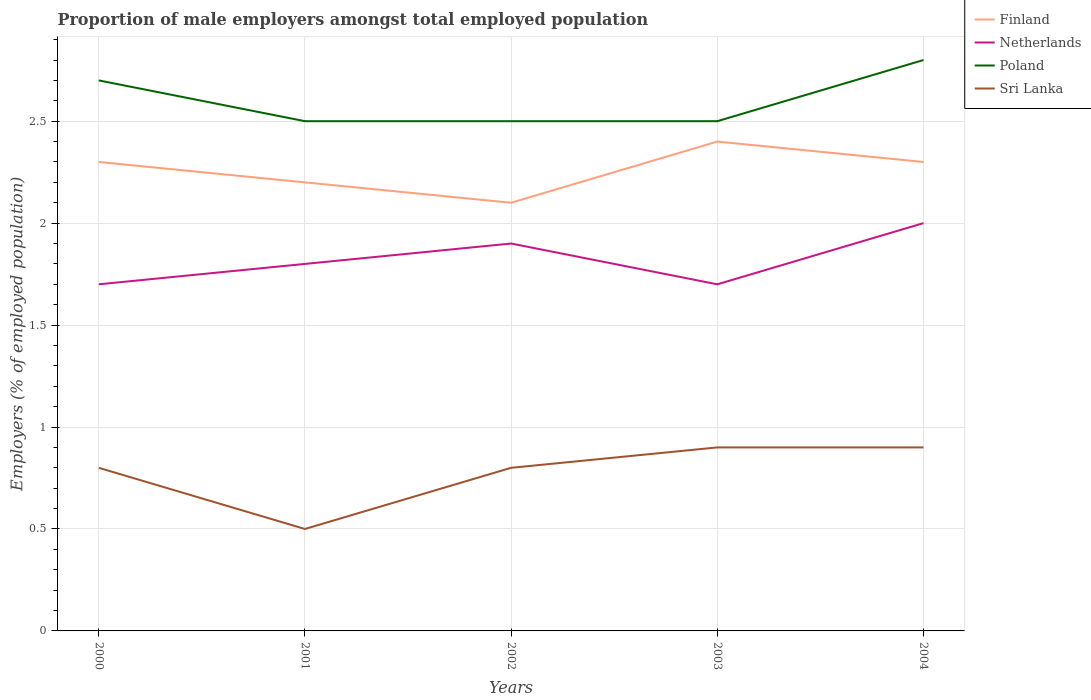How many different coloured lines are there?
Your response must be concise. 4. Is the number of lines equal to the number of legend labels?
Offer a terse response. Yes. Across all years, what is the maximum proportion of male employers in Sri Lanka?
Your response must be concise. 0.5. In which year was the proportion of male employers in Sri Lanka maximum?
Ensure brevity in your answer.  2001. What is the total proportion of male employers in Netherlands in the graph?
Ensure brevity in your answer.  -0.1. What is the difference between the highest and the second highest proportion of male employers in Poland?
Offer a terse response. 0.3. What is the difference between the highest and the lowest proportion of male employers in Finland?
Your answer should be compact. 3. Is the proportion of male employers in Sri Lanka strictly greater than the proportion of male employers in Netherlands over the years?
Ensure brevity in your answer.  Yes. What is the difference between two consecutive major ticks on the Y-axis?
Provide a succinct answer. 0.5. Are the values on the major ticks of Y-axis written in scientific E-notation?
Provide a short and direct response. No. Does the graph contain any zero values?
Provide a short and direct response. No. Does the graph contain grids?
Make the answer very short. Yes. What is the title of the graph?
Provide a short and direct response. Proportion of male employers amongst total employed population. Does "Hong Kong" appear as one of the legend labels in the graph?
Your answer should be compact. No. What is the label or title of the Y-axis?
Offer a very short reply. Employers (% of employed population). What is the Employers (% of employed population) in Finland in 2000?
Keep it short and to the point. 2.3. What is the Employers (% of employed population) in Netherlands in 2000?
Your answer should be very brief. 1.7. What is the Employers (% of employed population) of Poland in 2000?
Provide a short and direct response. 2.7. What is the Employers (% of employed population) in Sri Lanka in 2000?
Offer a terse response. 0.8. What is the Employers (% of employed population) of Finland in 2001?
Give a very brief answer. 2.2. What is the Employers (% of employed population) of Netherlands in 2001?
Make the answer very short. 1.8. What is the Employers (% of employed population) in Poland in 2001?
Offer a very short reply. 2.5. What is the Employers (% of employed population) of Finland in 2002?
Provide a short and direct response. 2.1. What is the Employers (% of employed population) of Netherlands in 2002?
Your response must be concise. 1.9. What is the Employers (% of employed population) of Sri Lanka in 2002?
Provide a succinct answer. 0.8. What is the Employers (% of employed population) in Finland in 2003?
Your response must be concise. 2.4. What is the Employers (% of employed population) of Netherlands in 2003?
Ensure brevity in your answer.  1.7. What is the Employers (% of employed population) of Sri Lanka in 2003?
Provide a short and direct response. 0.9. What is the Employers (% of employed population) in Finland in 2004?
Offer a very short reply. 2.3. What is the Employers (% of employed population) of Poland in 2004?
Your answer should be very brief. 2.8. What is the Employers (% of employed population) in Sri Lanka in 2004?
Offer a very short reply. 0.9. Across all years, what is the maximum Employers (% of employed population) of Finland?
Your response must be concise. 2.4. Across all years, what is the maximum Employers (% of employed population) of Netherlands?
Your response must be concise. 2. Across all years, what is the maximum Employers (% of employed population) of Poland?
Provide a short and direct response. 2.8. Across all years, what is the maximum Employers (% of employed population) in Sri Lanka?
Provide a succinct answer. 0.9. Across all years, what is the minimum Employers (% of employed population) of Finland?
Keep it short and to the point. 2.1. Across all years, what is the minimum Employers (% of employed population) of Netherlands?
Make the answer very short. 1.7. Across all years, what is the minimum Employers (% of employed population) of Sri Lanka?
Your answer should be very brief. 0.5. What is the total Employers (% of employed population) in Finland in the graph?
Offer a very short reply. 11.3. What is the total Employers (% of employed population) in Netherlands in the graph?
Provide a short and direct response. 9.1. What is the total Employers (% of employed population) of Poland in the graph?
Make the answer very short. 13. What is the total Employers (% of employed population) in Sri Lanka in the graph?
Keep it short and to the point. 3.9. What is the difference between the Employers (% of employed population) of Poland in 2000 and that in 2001?
Offer a very short reply. 0.2. What is the difference between the Employers (% of employed population) of Netherlands in 2000 and that in 2002?
Provide a short and direct response. -0.2. What is the difference between the Employers (% of employed population) in Poland in 2000 and that in 2002?
Your response must be concise. 0.2. What is the difference between the Employers (% of employed population) of Sri Lanka in 2000 and that in 2002?
Your answer should be very brief. 0. What is the difference between the Employers (% of employed population) in Finland in 2000 and that in 2003?
Your answer should be very brief. -0.1. What is the difference between the Employers (% of employed population) in Poland in 2000 and that in 2003?
Provide a short and direct response. 0.2. What is the difference between the Employers (% of employed population) of Netherlands in 2000 and that in 2004?
Offer a terse response. -0.3. What is the difference between the Employers (% of employed population) in Sri Lanka in 2000 and that in 2004?
Give a very brief answer. -0.1. What is the difference between the Employers (% of employed population) in Finland in 2001 and that in 2002?
Provide a short and direct response. 0.1. What is the difference between the Employers (% of employed population) in Netherlands in 2001 and that in 2002?
Make the answer very short. -0.1. What is the difference between the Employers (% of employed population) in Poland in 2001 and that in 2002?
Your answer should be compact. 0. What is the difference between the Employers (% of employed population) of Netherlands in 2001 and that in 2003?
Give a very brief answer. 0.1. What is the difference between the Employers (% of employed population) in Poland in 2001 and that in 2004?
Make the answer very short. -0.3. What is the difference between the Employers (% of employed population) of Sri Lanka in 2001 and that in 2004?
Offer a very short reply. -0.4. What is the difference between the Employers (% of employed population) in Finland in 2002 and that in 2003?
Make the answer very short. -0.3. What is the difference between the Employers (% of employed population) of Poland in 2002 and that in 2003?
Provide a short and direct response. 0. What is the difference between the Employers (% of employed population) of Finland in 2002 and that in 2004?
Your answer should be very brief. -0.2. What is the difference between the Employers (% of employed population) in Poland in 2002 and that in 2004?
Your answer should be very brief. -0.3. What is the difference between the Employers (% of employed population) in Poland in 2003 and that in 2004?
Keep it short and to the point. -0.3. What is the difference between the Employers (% of employed population) in Netherlands in 2000 and the Employers (% of employed population) in Sri Lanka in 2001?
Make the answer very short. 1.2. What is the difference between the Employers (% of employed population) in Poland in 2000 and the Employers (% of employed population) in Sri Lanka in 2001?
Provide a short and direct response. 2.2. What is the difference between the Employers (% of employed population) in Finland in 2000 and the Employers (% of employed population) in Poland in 2002?
Your answer should be very brief. -0.2. What is the difference between the Employers (% of employed population) of Finland in 2000 and the Employers (% of employed population) of Poland in 2003?
Provide a short and direct response. -0.2. What is the difference between the Employers (% of employed population) of Netherlands in 2000 and the Employers (% of employed population) of Poland in 2003?
Your answer should be compact. -0.8. What is the difference between the Employers (% of employed population) of Netherlands in 2000 and the Employers (% of employed population) of Sri Lanka in 2003?
Offer a terse response. 0.8. What is the difference between the Employers (% of employed population) of Finland in 2000 and the Employers (% of employed population) of Netherlands in 2004?
Your response must be concise. 0.3. What is the difference between the Employers (% of employed population) in Finland in 2000 and the Employers (% of employed population) in Poland in 2004?
Your answer should be very brief. -0.5. What is the difference between the Employers (% of employed population) in Finland in 2000 and the Employers (% of employed population) in Sri Lanka in 2004?
Your answer should be compact. 1.4. What is the difference between the Employers (% of employed population) of Finland in 2001 and the Employers (% of employed population) of Sri Lanka in 2002?
Your response must be concise. 1.4. What is the difference between the Employers (% of employed population) of Netherlands in 2001 and the Employers (% of employed population) of Poland in 2002?
Provide a succinct answer. -0.7. What is the difference between the Employers (% of employed population) in Netherlands in 2001 and the Employers (% of employed population) in Sri Lanka in 2002?
Provide a short and direct response. 1. What is the difference between the Employers (% of employed population) of Poland in 2001 and the Employers (% of employed population) of Sri Lanka in 2002?
Keep it short and to the point. 1.7. What is the difference between the Employers (% of employed population) in Finland in 2001 and the Employers (% of employed population) in Netherlands in 2003?
Make the answer very short. 0.5. What is the difference between the Employers (% of employed population) in Finland in 2001 and the Employers (% of employed population) in Poland in 2003?
Give a very brief answer. -0.3. What is the difference between the Employers (% of employed population) in Finland in 2001 and the Employers (% of employed population) in Sri Lanka in 2003?
Provide a succinct answer. 1.3. What is the difference between the Employers (% of employed population) in Netherlands in 2001 and the Employers (% of employed population) in Poland in 2003?
Give a very brief answer. -0.7. What is the difference between the Employers (% of employed population) of Finland in 2001 and the Employers (% of employed population) of Poland in 2004?
Ensure brevity in your answer.  -0.6. What is the difference between the Employers (% of employed population) of Netherlands in 2001 and the Employers (% of employed population) of Sri Lanka in 2004?
Keep it short and to the point. 0.9. What is the difference between the Employers (% of employed population) of Finland in 2002 and the Employers (% of employed population) of Poland in 2003?
Offer a very short reply. -0.4. What is the difference between the Employers (% of employed population) of Finland in 2002 and the Employers (% of employed population) of Sri Lanka in 2003?
Provide a succinct answer. 1.2. What is the difference between the Employers (% of employed population) in Netherlands in 2002 and the Employers (% of employed population) in Poland in 2003?
Offer a very short reply. -0.6. What is the difference between the Employers (% of employed population) in Netherlands in 2002 and the Employers (% of employed population) in Sri Lanka in 2003?
Provide a short and direct response. 1. What is the difference between the Employers (% of employed population) in Poland in 2002 and the Employers (% of employed population) in Sri Lanka in 2003?
Give a very brief answer. 1.6. What is the difference between the Employers (% of employed population) of Finland in 2002 and the Employers (% of employed population) of Netherlands in 2004?
Your response must be concise. 0.1. What is the difference between the Employers (% of employed population) in Finland in 2002 and the Employers (% of employed population) in Sri Lanka in 2004?
Your response must be concise. 1.2. What is the difference between the Employers (% of employed population) of Netherlands in 2002 and the Employers (% of employed population) of Poland in 2004?
Make the answer very short. -0.9. What is the difference between the Employers (% of employed population) in Finland in 2003 and the Employers (% of employed population) in Poland in 2004?
Offer a terse response. -0.4. What is the difference between the Employers (% of employed population) of Netherlands in 2003 and the Employers (% of employed population) of Poland in 2004?
Your answer should be very brief. -1.1. What is the difference between the Employers (% of employed population) of Poland in 2003 and the Employers (% of employed population) of Sri Lanka in 2004?
Make the answer very short. 1.6. What is the average Employers (% of employed population) of Finland per year?
Make the answer very short. 2.26. What is the average Employers (% of employed population) in Netherlands per year?
Your answer should be very brief. 1.82. What is the average Employers (% of employed population) in Sri Lanka per year?
Make the answer very short. 0.78. In the year 2000, what is the difference between the Employers (% of employed population) of Finland and Employers (% of employed population) of Netherlands?
Provide a succinct answer. 0.6. In the year 2000, what is the difference between the Employers (% of employed population) in Finland and Employers (% of employed population) in Poland?
Provide a short and direct response. -0.4. In the year 2000, what is the difference between the Employers (% of employed population) in Netherlands and Employers (% of employed population) in Poland?
Keep it short and to the point. -1. In the year 2001, what is the difference between the Employers (% of employed population) in Finland and Employers (% of employed population) in Poland?
Provide a succinct answer. -0.3. In the year 2001, what is the difference between the Employers (% of employed population) in Finland and Employers (% of employed population) in Sri Lanka?
Your response must be concise. 1.7. In the year 2001, what is the difference between the Employers (% of employed population) of Netherlands and Employers (% of employed population) of Sri Lanka?
Your answer should be very brief. 1.3. In the year 2002, what is the difference between the Employers (% of employed population) of Poland and Employers (% of employed population) of Sri Lanka?
Keep it short and to the point. 1.7. In the year 2003, what is the difference between the Employers (% of employed population) in Finland and Employers (% of employed population) in Poland?
Keep it short and to the point. -0.1. In the year 2003, what is the difference between the Employers (% of employed population) in Finland and Employers (% of employed population) in Sri Lanka?
Your answer should be very brief. 1.5. In the year 2003, what is the difference between the Employers (% of employed population) in Poland and Employers (% of employed population) in Sri Lanka?
Provide a short and direct response. 1.6. In the year 2004, what is the difference between the Employers (% of employed population) in Finland and Employers (% of employed population) in Netherlands?
Your answer should be compact. 0.3. In the year 2004, what is the difference between the Employers (% of employed population) of Finland and Employers (% of employed population) of Poland?
Make the answer very short. -0.5. What is the ratio of the Employers (% of employed population) of Finland in 2000 to that in 2001?
Offer a terse response. 1.05. What is the ratio of the Employers (% of employed population) of Netherlands in 2000 to that in 2001?
Make the answer very short. 0.94. What is the ratio of the Employers (% of employed population) of Poland in 2000 to that in 2001?
Your answer should be very brief. 1.08. What is the ratio of the Employers (% of employed population) of Finland in 2000 to that in 2002?
Ensure brevity in your answer.  1.1. What is the ratio of the Employers (% of employed population) of Netherlands in 2000 to that in 2002?
Provide a succinct answer. 0.89. What is the ratio of the Employers (% of employed population) in Sri Lanka in 2000 to that in 2002?
Provide a short and direct response. 1. What is the ratio of the Employers (% of employed population) in Finland in 2000 to that in 2003?
Your answer should be very brief. 0.96. What is the ratio of the Employers (% of employed population) of Sri Lanka in 2000 to that in 2003?
Your response must be concise. 0.89. What is the ratio of the Employers (% of employed population) in Netherlands in 2000 to that in 2004?
Give a very brief answer. 0.85. What is the ratio of the Employers (% of employed population) in Sri Lanka in 2000 to that in 2004?
Your answer should be compact. 0.89. What is the ratio of the Employers (% of employed population) of Finland in 2001 to that in 2002?
Your answer should be compact. 1.05. What is the ratio of the Employers (% of employed population) of Netherlands in 2001 to that in 2002?
Your answer should be very brief. 0.95. What is the ratio of the Employers (% of employed population) in Poland in 2001 to that in 2002?
Offer a very short reply. 1. What is the ratio of the Employers (% of employed population) of Finland in 2001 to that in 2003?
Give a very brief answer. 0.92. What is the ratio of the Employers (% of employed population) of Netherlands in 2001 to that in 2003?
Give a very brief answer. 1.06. What is the ratio of the Employers (% of employed population) of Sri Lanka in 2001 to that in 2003?
Make the answer very short. 0.56. What is the ratio of the Employers (% of employed population) in Finland in 2001 to that in 2004?
Your answer should be compact. 0.96. What is the ratio of the Employers (% of employed population) of Poland in 2001 to that in 2004?
Offer a terse response. 0.89. What is the ratio of the Employers (% of employed population) of Sri Lanka in 2001 to that in 2004?
Your answer should be compact. 0.56. What is the ratio of the Employers (% of employed population) of Netherlands in 2002 to that in 2003?
Provide a short and direct response. 1.12. What is the ratio of the Employers (% of employed population) of Poland in 2002 to that in 2003?
Your answer should be compact. 1. What is the ratio of the Employers (% of employed population) in Netherlands in 2002 to that in 2004?
Your response must be concise. 0.95. What is the ratio of the Employers (% of employed population) in Poland in 2002 to that in 2004?
Provide a short and direct response. 0.89. What is the ratio of the Employers (% of employed population) of Sri Lanka in 2002 to that in 2004?
Give a very brief answer. 0.89. What is the ratio of the Employers (% of employed population) of Finland in 2003 to that in 2004?
Provide a succinct answer. 1.04. What is the ratio of the Employers (% of employed population) of Netherlands in 2003 to that in 2004?
Ensure brevity in your answer.  0.85. What is the ratio of the Employers (% of employed population) in Poland in 2003 to that in 2004?
Offer a terse response. 0.89. What is the ratio of the Employers (% of employed population) in Sri Lanka in 2003 to that in 2004?
Make the answer very short. 1. What is the difference between the highest and the second highest Employers (% of employed population) in Netherlands?
Your response must be concise. 0.1. What is the difference between the highest and the lowest Employers (% of employed population) in Poland?
Provide a short and direct response. 0.3. What is the difference between the highest and the lowest Employers (% of employed population) in Sri Lanka?
Your answer should be very brief. 0.4. 